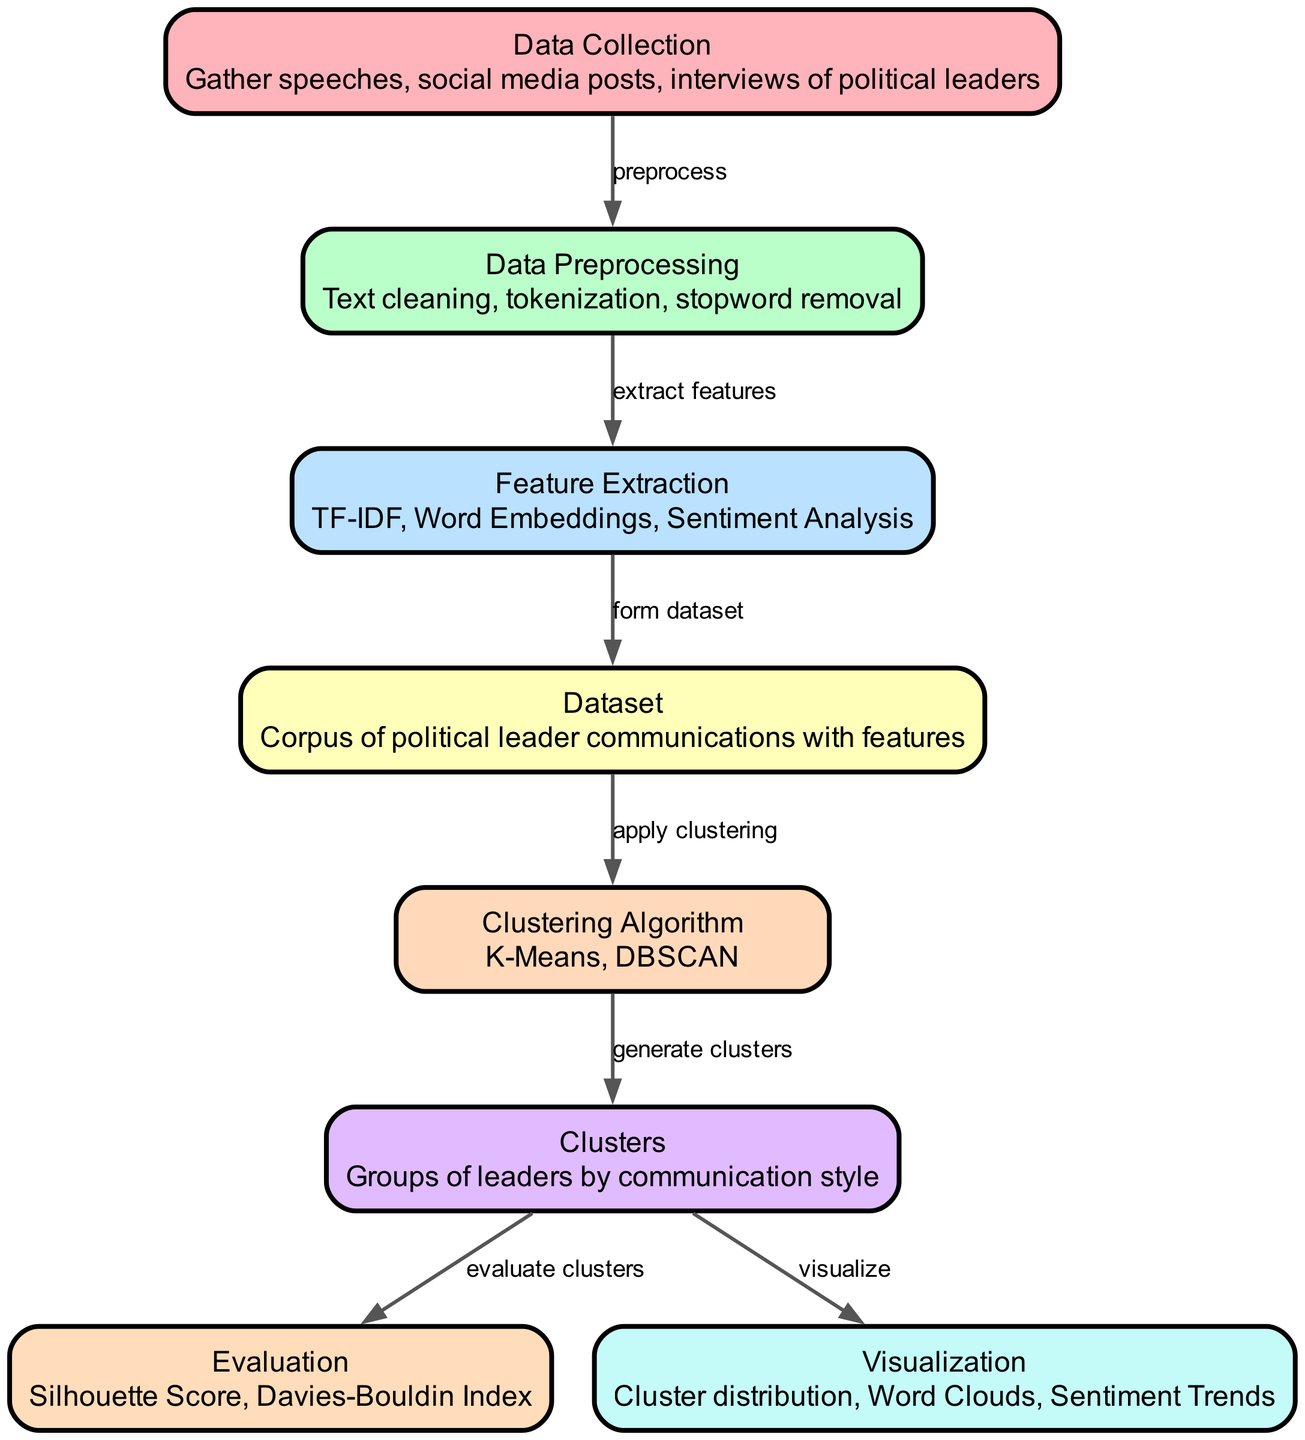What is the first step in the process? The first step in the process is labeled "Data Collection," which indicates that this involves gathering speeches, social media posts, and interviews of political leaders.
Answer: Data Collection How many nodes are present in the diagram? By counting the nodes listed in the data, we can see that there are a total of eight nodes present in the diagram.
Answer: Eight Which algorithm is used for clustering? The diagram mentions the "Clustering Algorithm" node, which includes K-Means and DBSCAN as the techniques used for clustering the data.
Answer: K-Means, DBSCAN What follows after data preprocessing? The flow from "Data Preprocessing" leads to "Feature Extraction," indicating that feature extraction is the next step after data preprocessing.
Answer: Feature Extraction What metric is used to evaluate clusters? The node labeled "Evaluation" specifies the metrics used for evaluation, which include the Silhouette Score and Davies-Bouldin Index.
Answer: Silhouette Score, Davies-Bouldin Index Which node represents the final output of clustering? The "Clusters" node indicates the output, where groups of leaders by their communication styles are represented as the result of the clustering process.
Answer: Clusters What is the main purpose of the visualization step? The "Visualization" node contains elements like cluster distribution, word clouds, and sentiment trends to illustrate the results of the clustering process visually.
Answer: Visualize Which node comes after the dataset is formed? The flow indicates that after forming the dataset, the next step is to apply the clustering algorithm, connecting "Dataset" to "Clustering Algorithm."
Answer: Clustering Algorithm How many edges connect the nodes in the diagram? By reviewing the connections between nodes, we can count a total of seven edges present in the diagram representing the relationships between the steps.
Answer: Seven 